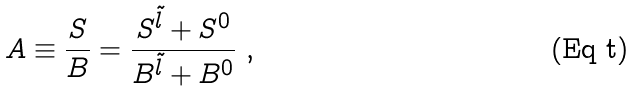<formula> <loc_0><loc_0><loc_500><loc_500>A \equiv \frac { S } { B } = \frac { S ^ { \tilde { l } } + S ^ { 0 } } { B ^ { \tilde { l } } + B ^ { 0 } } \ ,</formula> 